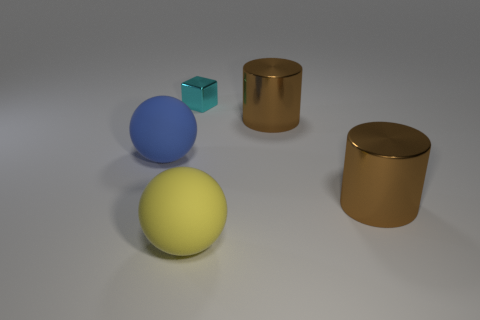The other rubber object that is the same size as the yellow thing is what color?
Offer a very short reply. Blue. What number of big objects are cubes or brown things?
Ensure brevity in your answer.  2. Is the number of small cyan metallic blocks in front of the cyan metal cube greater than the number of big cylinders that are in front of the large yellow rubber sphere?
Your answer should be very brief. No. What number of other things are the same size as the metal block?
Your answer should be compact. 0. Are the brown thing in front of the large blue rubber sphere and the tiny cyan object made of the same material?
Your answer should be compact. Yes. What number of other objects are there of the same color as the small cube?
Provide a succinct answer. 0. How many other things are there of the same shape as the tiny cyan metal thing?
Keep it short and to the point. 0. Does the blue thing behind the large yellow rubber ball have the same shape as the big brown thing that is in front of the large blue object?
Offer a terse response. No. Are there the same number of tiny cyan metallic blocks in front of the big yellow thing and spheres that are in front of the large blue matte ball?
Offer a terse response. No. What is the shape of the matte object behind the large matte thing in front of the big thing that is to the left of the cyan thing?
Keep it short and to the point. Sphere. 